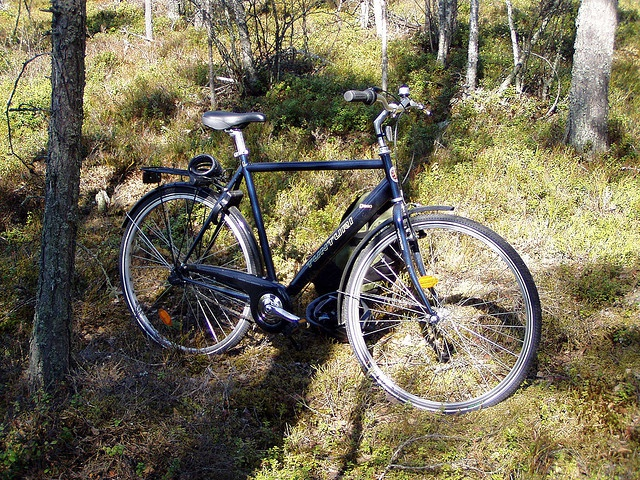Describe the objects in this image and their specific colors. I can see bicycle in gray, black, white, and darkgray tones and backpack in gray, black, white, and darkgray tones in this image. 